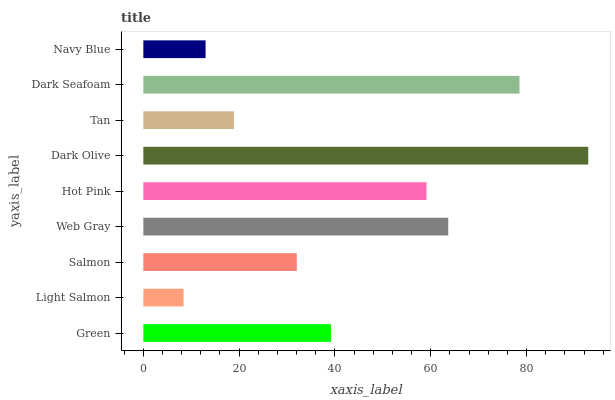Is Light Salmon the minimum?
Answer yes or no. Yes. Is Dark Olive the maximum?
Answer yes or no. Yes. Is Salmon the minimum?
Answer yes or no. No. Is Salmon the maximum?
Answer yes or no. No. Is Salmon greater than Light Salmon?
Answer yes or no. Yes. Is Light Salmon less than Salmon?
Answer yes or no. Yes. Is Light Salmon greater than Salmon?
Answer yes or no. No. Is Salmon less than Light Salmon?
Answer yes or no. No. Is Green the high median?
Answer yes or no. Yes. Is Green the low median?
Answer yes or no. Yes. Is Dark Olive the high median?
Answer yes or no. No. Is Tan the low median?
Answer yes or no. No. 